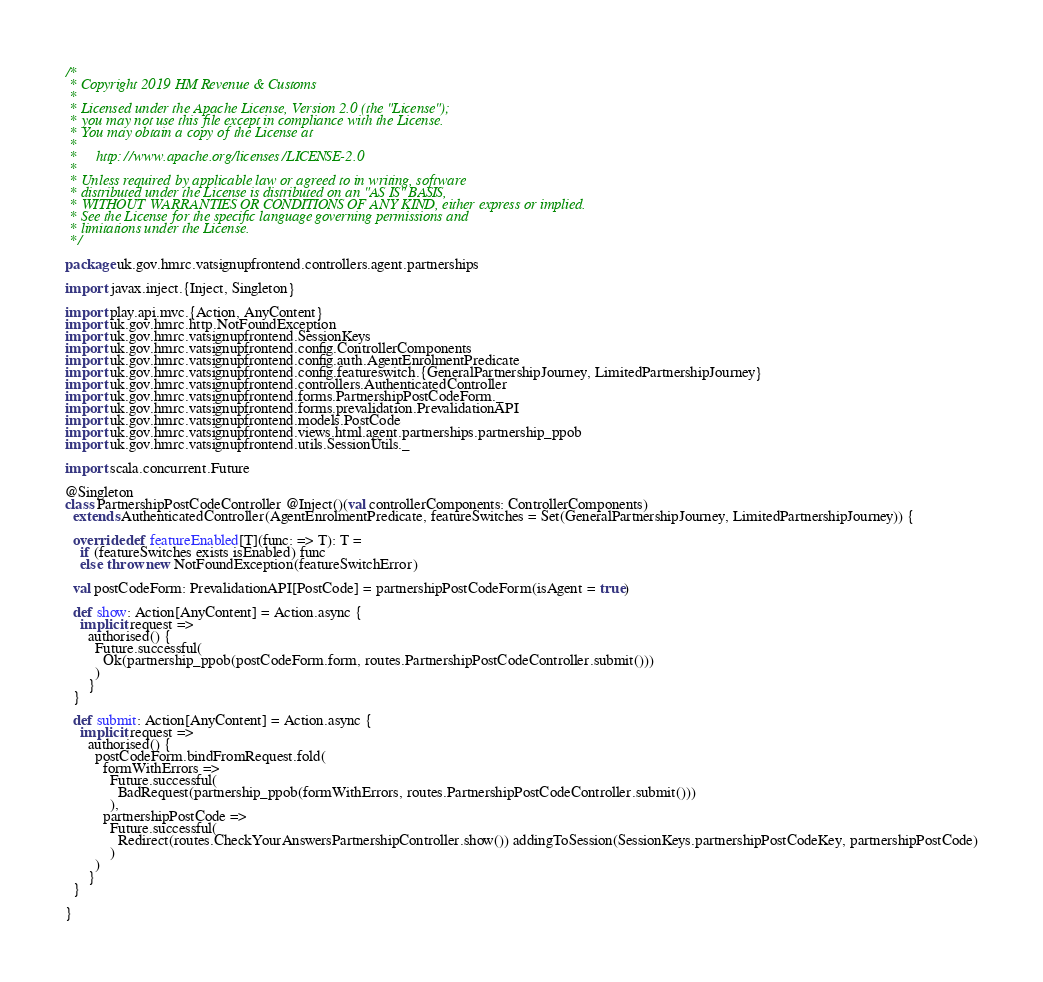Convert code to text. <code><loc_0><loc_0><loc_500><loc_500><_Scala_>/*
 * Copyright 2019 HM Revenue & Customs
 *
 * Licensed under the Apache License, Version 2.0 (the "License");
 * you may not use this file except in compliance with the License.
 * You may obtain a copy of the License at
 *
 *     http://www.apache.org/licenses/LICENSE-2.0
 *
 * Unless required by applicable law or agreed to in writing, software
 * distributed under the License is distributed on an "AS IS" BASIS,
 * WITHOUT WARRANTIES OR CONDITIONS OF ANY KIND, either express or implied.
 * See the License for the specific language governing permissions and
 * limitations under the License.
 */

package uk.gov.hmrc.vatsignupfrontend.controllers.agent.partnerships

import javax.inject.{Inject, Singleton}

import play.api.mvc.{Action, AnyContent}
import uk.gov.hmrc.http.NotFoundException
import uk.gov.hmrc.vatsignupfrontend.SessionKeys
import uk.gov.hmrc.vatsignupfrontend.config.ControllerComponents
import uk.gov.hmrc.vatsignupfrontend.config.auth.AgentEnrolmentPredicate
import uk.gov.hmrc.vatsignupfrontend.config.featureswitch.{GeneralPartnershipJourney, LimitedPartnershipJourney}
import uk.gov.hmrc.vatsignupfrontend.controllers.AuthenticatedController
import uk.gov.hmrc.vatsignupfrontend.forms.PartnershipPostCodeForm._
import uk.gov.hmrc.vatsignupfrontend.forms.prevalidation.PrevalidationAPI
import uk.gov.hmrc.vatsignupfrontend.models.PostCode
import uk.gov.hmrc.vatsignupfrontend.views.html.agent.partnerships.partnership_ppob
import uk.gov.hmrc.vatsignupfrontend.utils.SessionUtils._

import scala.concurrent.Future

@Singleton
class PartnershipPostCodeController @Inject()(val controllerComponents: ControllerComponents)
  extends AuthenticatedController(AgentEnrolmentPredicate, featureSwitches = Set(GeneralPartnershipJourney, LimitedPartnershipJourney)) {

  override def featureEnabled[T](func: => T): T =
    if (featureSwitches exists isEnabled) func
    else throw new NotFoundException(featureSwitchError)

  val postCodeForm: PrevalidationAPI[PostCode] = partnershipPostCodeForm(isAgent = true)

  def show: Action[AnyContent] = Action.async {
    implicit request =>
      authorised() {
        Future.successful(
          Ok(partnership_ppob(postCodeForm.form, routes.PartnershipPostCodeController.submit()))
        )
      }
  }

  def submit: Action[AnyContent] = Action.async {
    implicit request =>
      authorised() {
        postCodeForm.bindFromRequest.fold(
          formWithErrors =>
            Future.successful(
              BadRequest(partnership_ppob(formWithErrors, routes.PartnershipPostCodeController.submit()))
            ),
          partnershipPostCode =>
            Future.successful(
              Redirect(routes.CheckYourAnswersPartnershipController.show()) addingToSession(SessionKeys.partnershipPostCodeKey, partnershipPostCode)
            )
        )
      }
  }

}
</code> 